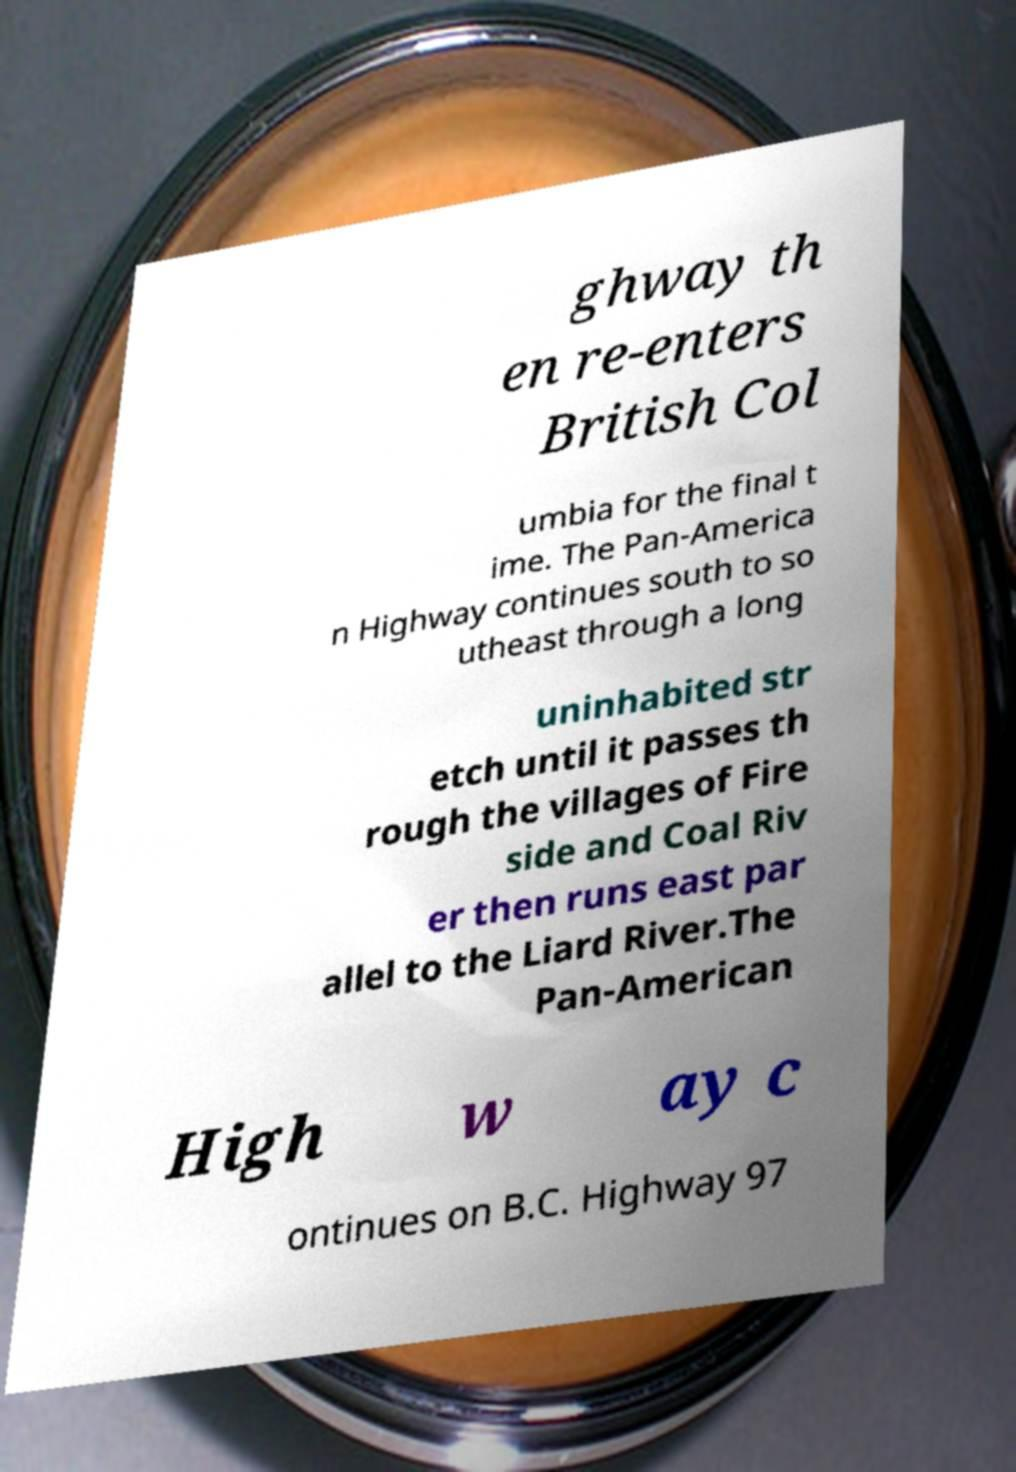What messages or text are displayed in this image? I need them in a readable, typed format. ghway th en re-enters British Col umbia for the final t ime. The Pan-America n Highway continues south to so utheast through a long uninhabited str etch until it passes th rough the villages of Fire side and Coal Riv er then runs east par allel to the Liard River.The Pan-American High w ay c ontinues on B.C. Highway 97 